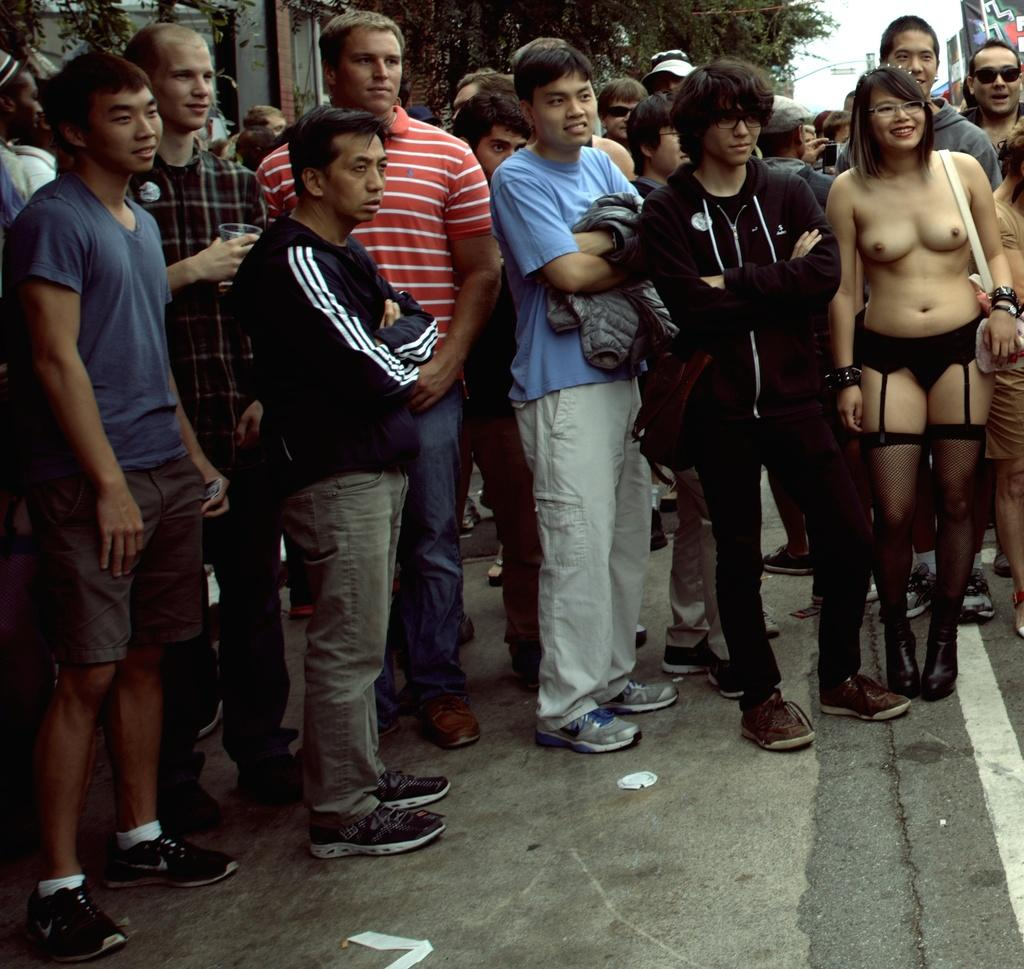What can be seen in the front of the image? There are people standing in the front of the image. What direction are the people looking? The people are looking to the right side. What type of natural scenery is visible in the background? There are trees in the background of the image. What type of man-made structure can be seen in the image? There is a road visible in the front bottom side of the image. What advice is being given to the people in the image? There is no indication in the image that any advice is being given to the people. What type of home can be seen in the image? There is no home visible in the image; it primarily features people, trees, and a road. 